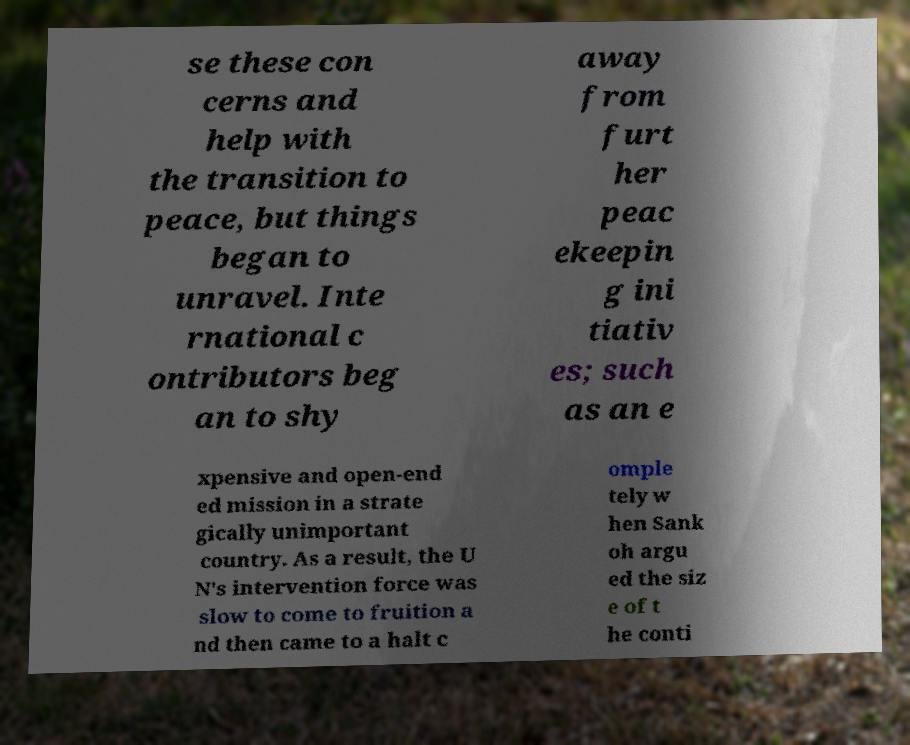Can you accurately transcribe the text from the provided image for me? se these con cerns and help with the transition to peace, but things began to unravel. Inte rnational c ontributors beg an to shy away from furt her peac ekeepin g ini tiativ es; such as an e xpensive and open-end ed mission in a strate gically unimportant country. As a result, the U N's intervention force was slow to come to fruition a nd then came to a halt c omple tely w hen Sank oh argu ed the siz e of t he conti 